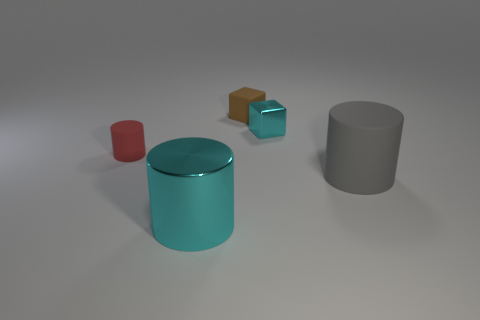Subtract all tiny cylinders. How many cylinders are left? 2 Subtract all gray cylinders. How many cylinders are left? 2 Subtract 2 blocks. How many blocks are left? 0 Subtract all yellow cylinders. Subtract all green balls. How many cylinders are left? 3 Subtract all green cylinders. How many cyan cubes are left? 1 Subtract all cyan cylinders. Subtract all small brown objects. How many objects are left? 3 Add 1 tiny cyan blocks. How many tiny cyan blocks are left? 2 Add 1 matte cylinders. How many matte cylinders exist? 3 Add 3 gray matte objects. How many objects exist? 8 Subtract 0 yellow blocks. How many objects are left? 5 